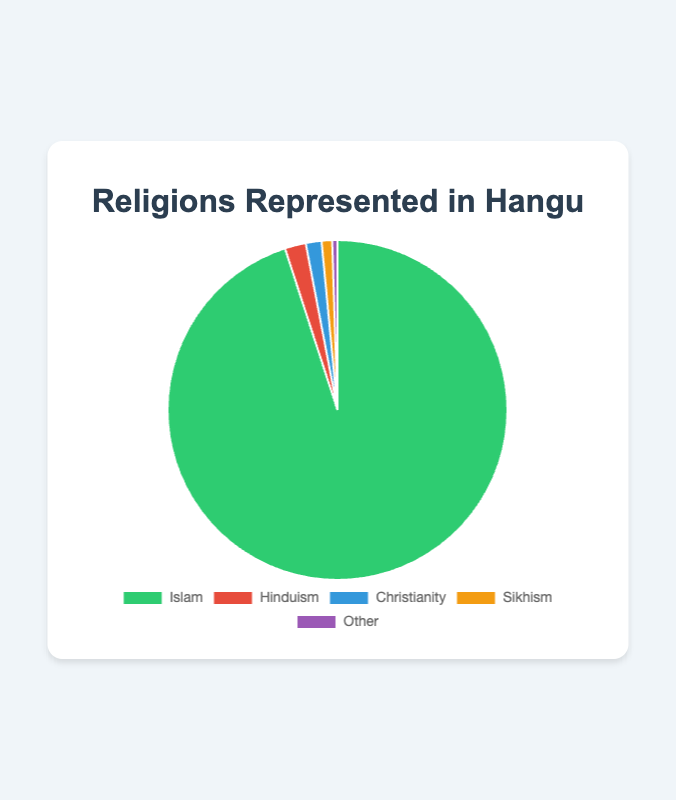What is the largest religious group represented in Hangu? The pie chart shows several religions and their percentages. The largest segment represents Islam with 95%.
Answer: Islam Which two religions have the smallest representation in Hangu? By looking at the pie chart, we identify the smallest segments. Sikhism is 1% and Other is 0.5%.
Answer: Sikhism and Other What is the combined percentage of Christianity and Hinduism in Hangu? The percentage of Christianity is 1.5% and Hinduism is 2%. Adding these gives 1.5% + 2% = 3.5%.
Answer: 3.5% How much larger is the Muslim population compared to the Sikh population in Hangu? The Muslim population is 95% and the Sikh population is 1%. The difference is 95% - 1% = 94%.
Answer: 94% Which religion is represented by the green segment in the pie chart? According to the color legend in the chart, the green segment corresponds to Islam.
Answer: Islam What percentage of the population does not follow Islam in Hangu? By subtracting the percentage of Muslims from 100%, 100% - 95% = 5%.
Answer: 5% What are the colors representing Hinduism and Christianity in the pie chart? Based on the color legend, Hinduism is represented by red and Christianity by blue.
Answer: Red and blue How do the percentages of Sikhism and Other religions compare? The chart shows Sikhism at 1% and Other at 0.5%. Sikhism is larger by 0.5%.
Answer: Sikhism is larger by 0.5% What is the average percentage of the non-Islamic religions in Hangu? Non-Islamic religions are Hinduism (2%), Christianity (1.5%), Sikhism (1%), and Other (0.5%). The sum is 5% and the average is 5%/4 = 1.25%.
Answer: 1.25% If you combine the representations of Sikhism and Christianity, how does their total compare to Hinduism? Sikhism and Christianity together make up 1% + 1.5% = 2.5%, which is 0.5% more than Hinduism’s 2%.
Answer: 0.5% more 